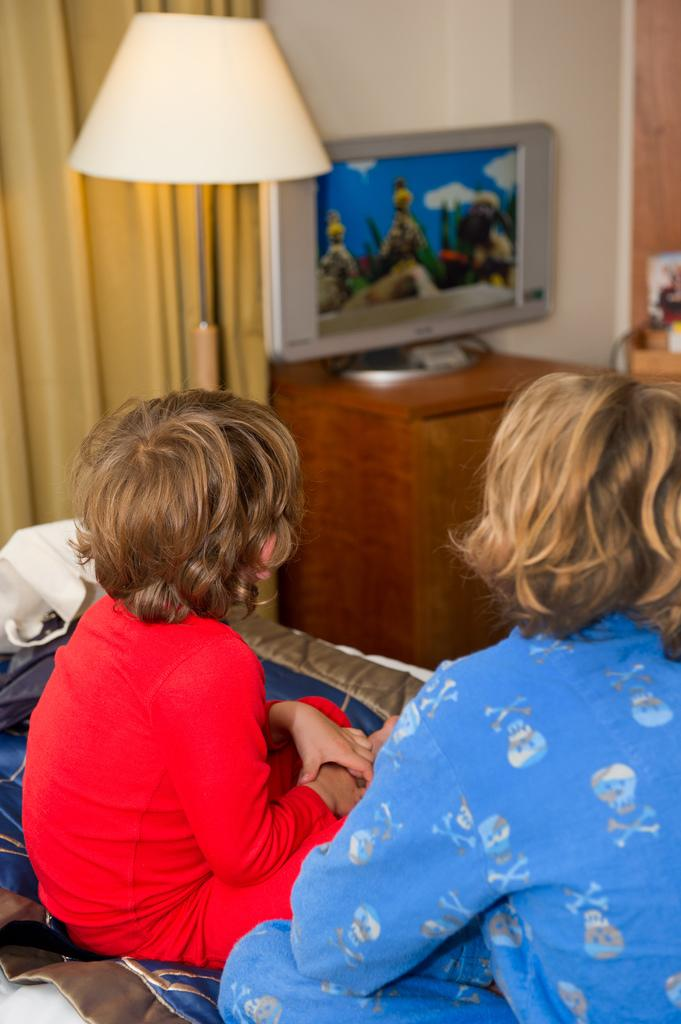How many children are in the image? There are two children in the image. What are the children doing in the image? The children are sitting. What can be seen in the background of the image? There is a lamp, a TV on a table, and a curtain in the background of the image. What type of straw is being used by the children to gain knowledge in the image? There is no straw or knowledge-related activity present in the image. 